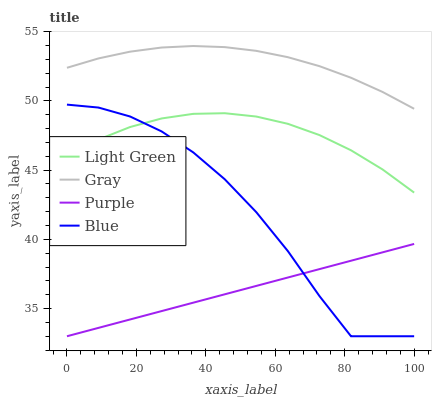Does Purple have the minimum area under the curve?
Answer yes or no. Yes. Does Gray have the maximum area under the curve?
Answer yes or no. Yes. Does Light Green have the minimum area under the curve?
Answer yes or no. No. Does Light Green have the maximum area under the curve?
Answer yes or no. No. Is Purple the smoothest?
Answer yes or no. Yes. Is Blue the roughest?
Answer yes or no. Yes. Is Gray the smoothest?
Answer yes or no. No. Is Gray the roughest?
Answer yes or no. No. Does Purple have the lowest value?
Answer yes or no. Yes. Does Light Green have the lowest value?
Answer yes or no. No. Does Gray have the highest value?
Answer yes or no. Yes. Does Light Green have the highest value?
Answer yes or no. No. Is Purple less than Gray?
Answer yes or no. Yes. Is Gray greater than Blue?
Answer yes or no. Yes. Does Blue intersect Light Green?
Answer yes or no. Yes. Is Blue less than Light Green?
Answer yes or no. No. Is Blue greater than Light Green?
Answer yes or no. No. Does Purple intersect Gray?
Answer yes or no. No. 